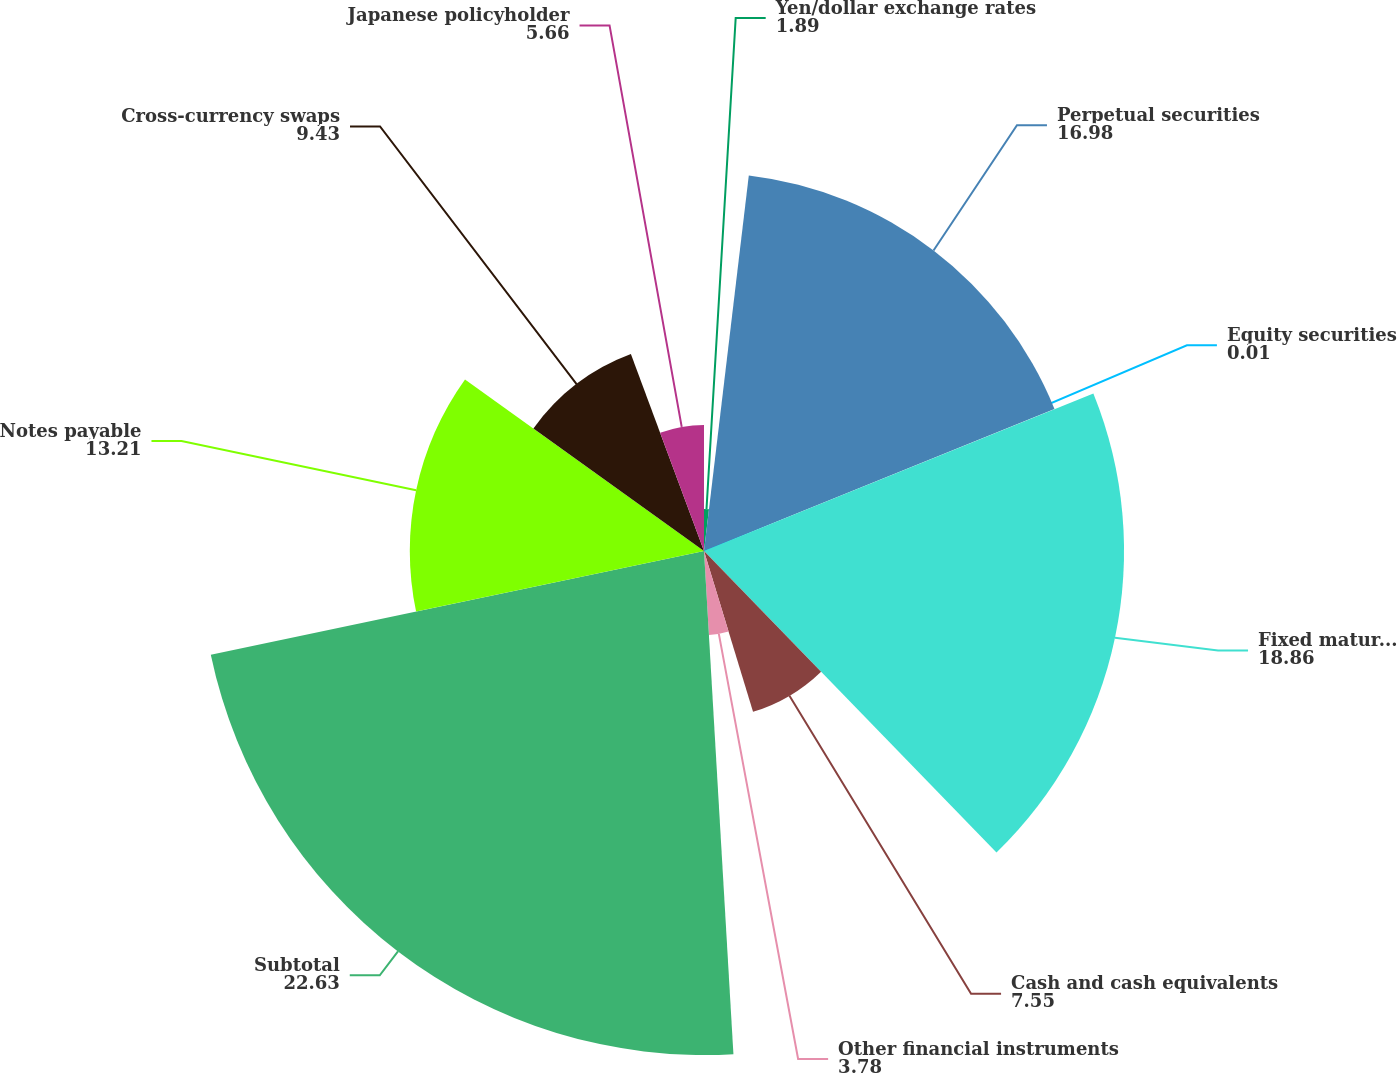Convert chart to OTSL. <chart><loc_0><loc_0><loc_500><loc_500><pie_chart><fcel>Yen/dollar exchange rates<fcel>Perpetual securities<fcel>Equity securities<fcel>Fixed maturities<fcel>Cash and cash equivalents<fcel>Other financial instruments<fcel>Subtotal<fcel>Notes payable<fcel>Cross-currency swaps<fcel>Japanese policyholder<nl><fcel>1.89%<fcel>16.98%<fcel>0.01%<fcel>18.86%<fcel>7.55%<fcel>3.78%<fcel>22.63%<fcel>13.21%<fcel>9.43%<fcel>5.66%<nl></chart> 